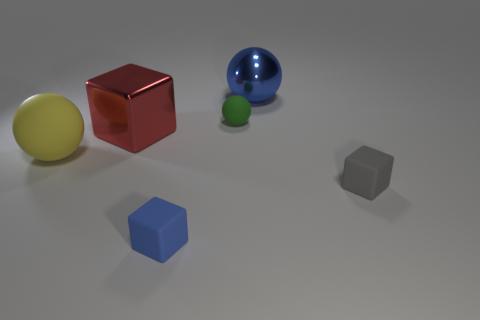Can you describe the lighting condition in the scene? The lighting in the image seems diffused, providing soft shadows under the objects, which suggests an indoor setting with a single or multiple light sources that are not directly visible, creating a calm and evenly lit environment. 